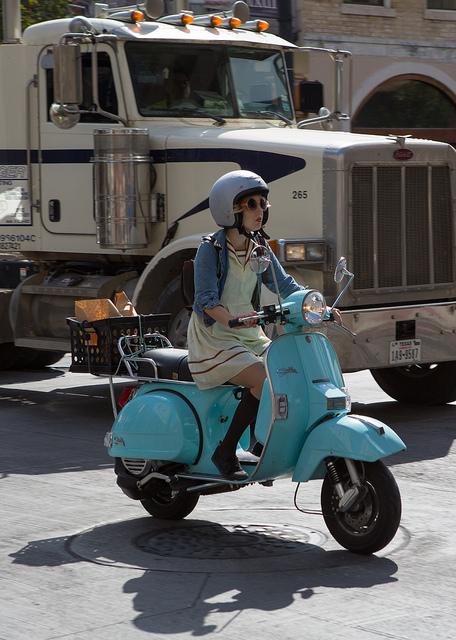Did this bike come with the basket on the back?
Be succinct. No. Are there stripes on her dress?
Be succinct. Yes. Is this in color?
Answer briefly. Yes. Why is this girl riding a bike?
Short answer required. To get somewhere. What kind of bike is it?
Quick response, please. Scooter. 